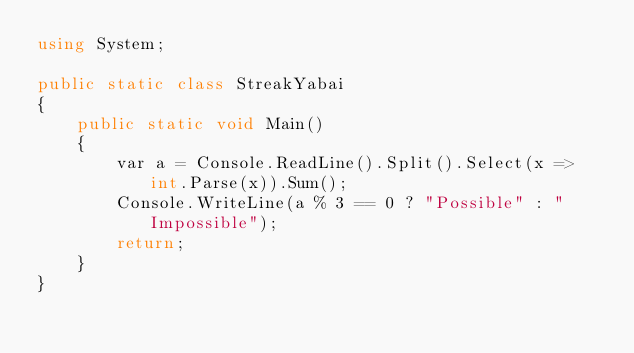Convert code to text. <code><loc_0><loc_0><loc_500><loc_500><_C#_>using System;

public static class StreakYabai
{
    public static void Main()
    {
        var a = Console.ReadLine().Split().Select(x => int.Parse(x)).Sum();
        Console.WriteLine(a % 3 == 0 ? "Possible" : "Impossible");
        return;
    }
}</code> 